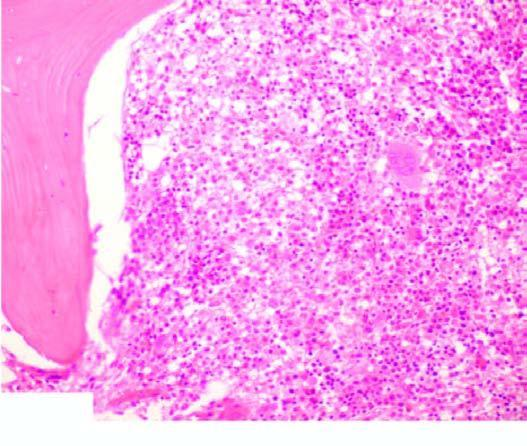does peripheral blood show presence of a leukaemic cells with hairy cytoplasmic projections?
Answer the question using a single word or phrase. Yes 